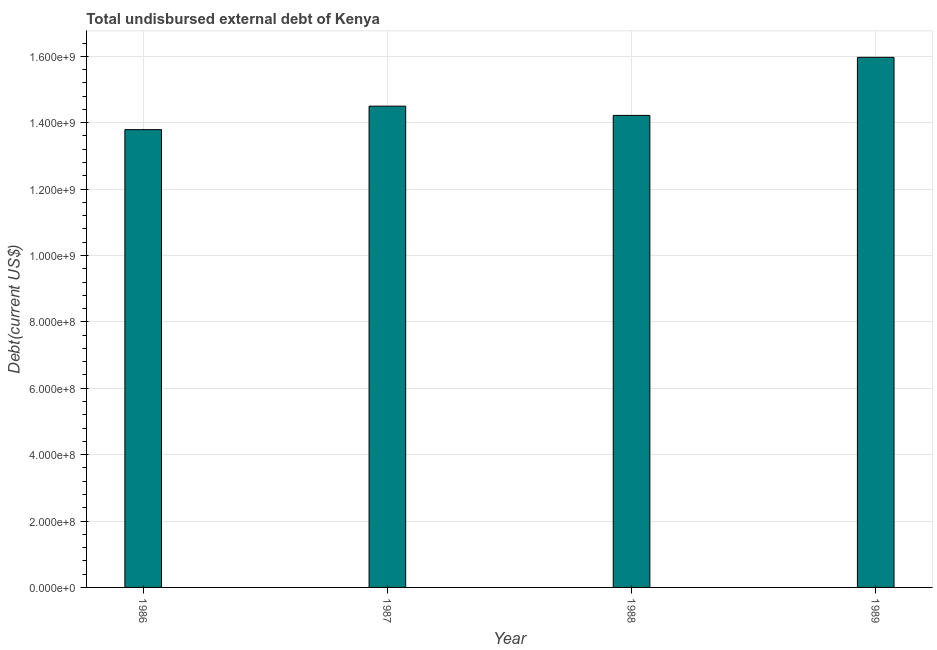Does the graph contain grids?
Offer a very short reply. Yes. What is the title of the graph?
Your answer should be very brief. Total undisbursed external debt of Kenya. What is the label or title of the Y-axis?
Your answer should be compact. Debt(current US$). What is the total debt in 1988?
Give a very brief answer. 1.42e+09. Across all years, what is the maximum total debt?
Make the answer very short. 1.60e+09. Across all years, what is the minimum total debt?
Offer a terse response. 1.38e+09. In which year was the total debt minimum?
Your answer should be compact. 1986. What is the sum of the total debt?
Provide a short and direct response. 5.85e+09. What is the difference between the total debt in 1988 and 1989?
Ensure brevity in your answer.  -1.75e+08. What is the average total debt per year?
Offer a terse response. 1.46e+09. What is the median total debt?
Offer a very short reply. 1.44e+09. Do a majority of the years between 1987 and 1989 (inclusive) have total debt greater than 1160000000 US$?
Your answer should be compact. Yes. What is the difference between the highest and the second highest total debt?
Give a very brief answer. 1.47e+08. Is the sum of the total debt in 1986 and 1989 greater than the maximum total debt across all years?
Offer a terse response. Yes. What is the difference between the highest and the lowest total debt?
Provide a succinct answer. 2.18e+08. In how many years, is the total debt greater than the average total debt taken over all years?
Your response must be concise. 1. How many bars are there?
Give a very brief answer. 4. How many years are there in the graph?
Provide a short and direct response. 4. What is the Debt(current US$) in 1986?
Provide a short and direct response. 1.38e+09. What is the Debt(current US$) in 1987?
Provide a short and direct response. 1.45e+09. What is the Debt(current US$) in 1988?
Provide a succinct answer. 1.42e+09. What is the Debt(current US$) of 1989?
Your answer should be very brief. 1.60e+09. What is the difference between the Debt(current US$) in 1986 and 1987?
Your response must be concise. -7.08e+07. What is the difference between the Debt(current US$) in 1986 and 1988?
Offer a terse response. -4.29e+07. What is the difference between the Debt(current US$) in 1986 and 1989?
Your answer should be compact. -2.18e+08. What is the difference between the Debt(current US$) in 1987 and 1988?
Your answer should be very brief. 2.78e+07. What is the difference between the Debt(current US$) in 1987 and 1989?
Offer a terse response. -1.47e+08. What is the difference between the Debt(current US$) in 1988 and 1989?
Make the answer very short. -1.75e+08. What is the ratio of the Debt(current US$) in 1986 to that in 1987?
Keep it short and to the point. 0.95. What is the ratio of the Debt(current US$) in 1986 to that in 1989?
Your response must be concise. 0.86. What is the ratio of the Debt(current US$) in 1987 to that in 1988?
Offer a very short reply. 1.02. What is the ratio of the Debt(current US$) in 1987 to that in 1989?
Make the answer very short. 0.91. What is the ratio of the Debt(current US$) in 1988 to that in 1989?
Keep it short and to the point. 0.89. 